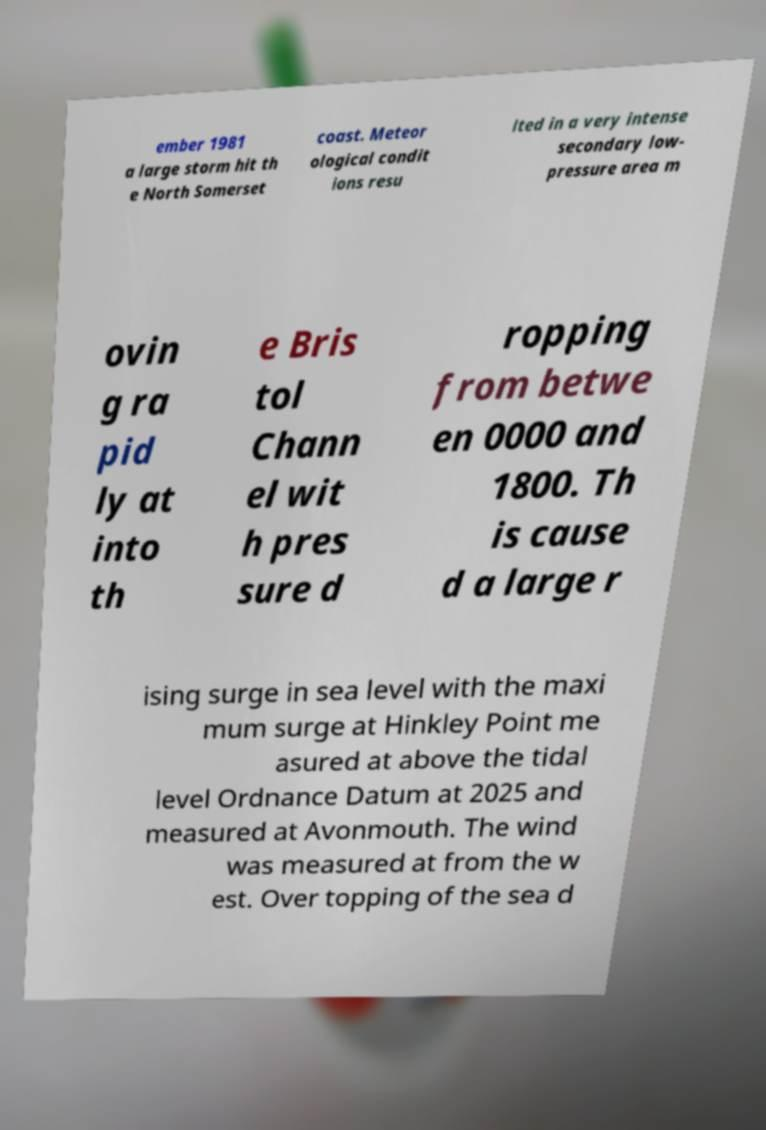What messages or text are displayed in this image? I need them in a readable, typed format. ember 1981 a large storm hit th e North Somerset coast. Meteor ological condit ions resu lted in a very intense secondary low- pressure area m ovin g ra pid ly at into th e Bris tol Chann el wit h pres sure d ropping from betwe en 0000 and 1800. Th is cause d a large r ising surge in sea level with the maxi mum surge at Hinkley Point me asured at above the tidal level Ordnance Datum at 2025 and measured at Avonmouth. The wind was measured at from the w est. Over topping of the sea d 